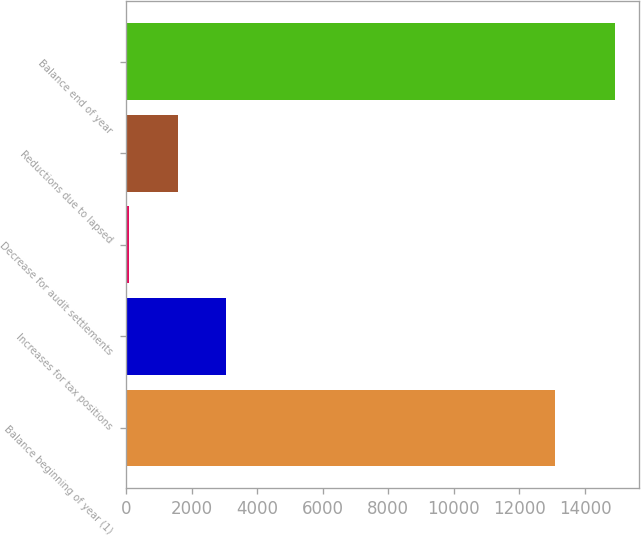<chart> <loc_0><loc_0><loc_500><loc_500><bar_chart><fcel>Balance beginning of year (1)<fcel>Increases for tax positions<fcel>Decrease for audit settlements<fcel>Reductions due to lapsed<fcel>Balance end of year<nl><fcel>13090<fcel>3056<fcel>93<fcel>1574.5<fcel>14908<nl></chart> 